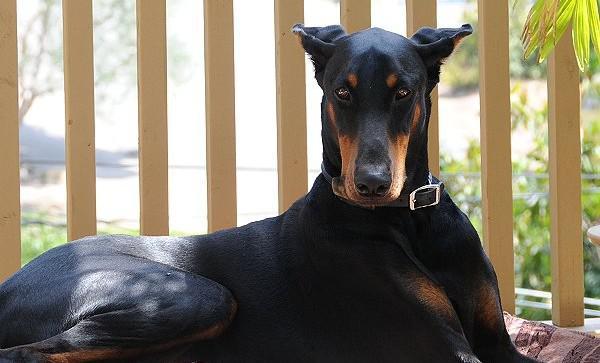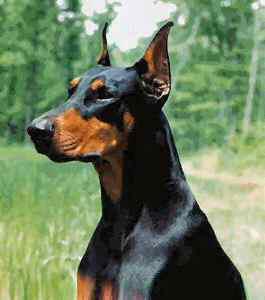The first image is the image on the left, the second image is the image on the right. Analyze the images presented: Is the assertion "A doberman has its mouth open." valid? Answer yes or no. No. The first image is the image on the left, the second image is the image on the right. For the images displayed, is the sentence "The left image contains a doberman with its mouth open wide and its fangs bared, and the right image contains at least one doberman with its body and gaze facing left." factually correct? Answer yes or no. No. 